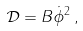Convert formula to latex. <formula><loc_0><loc_0><loc_500><loc_500>\mathcal { D } = B \dot { \phi } ^ { 2 } \, ,</formula> 